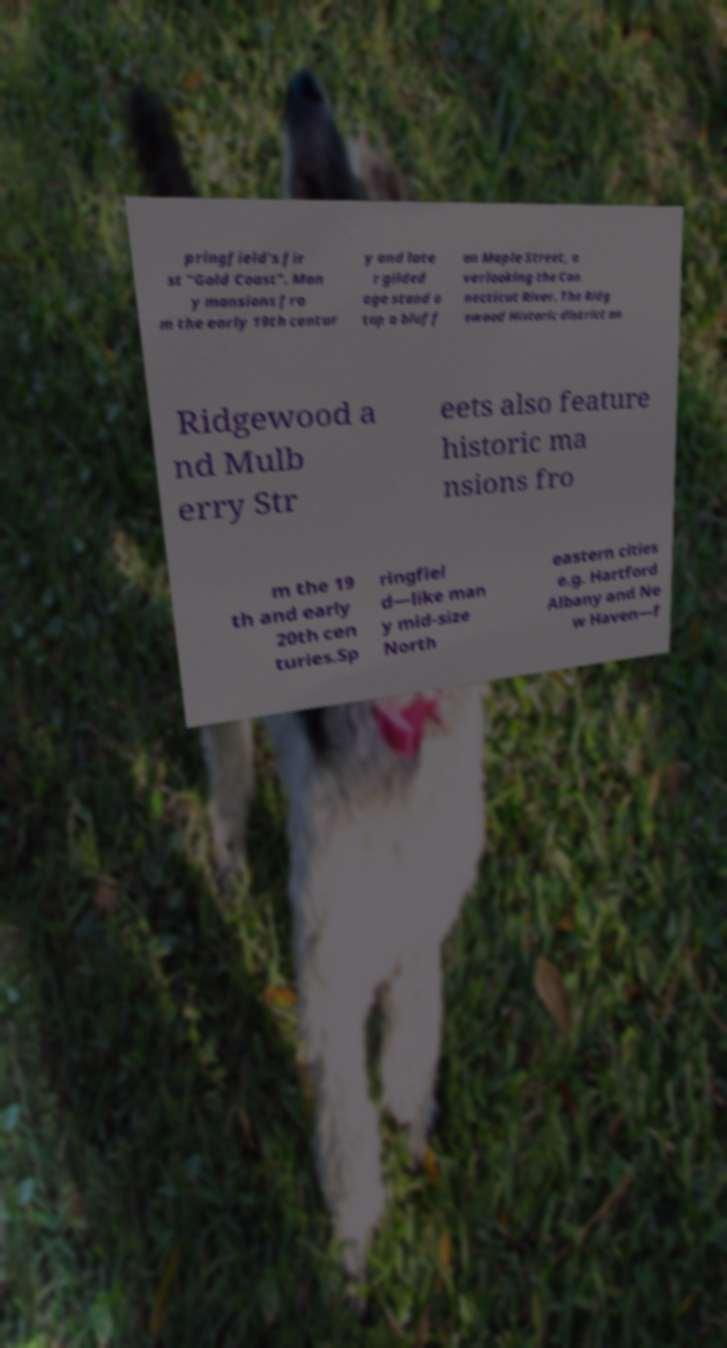Could you assist in decoding the text presented in this image and type it out clearly? pringfield's fir st "Gold Coast". Man y mansions fro m the early 19th centur y and late r gilded age stand a top a bluff on Maple Street, o verlooking the Con necticut River. The Ridg ewood Historic district on Ridgewood a nd Mulb erry Str eets also feature historic ma nsions fro m the 19 th and early 20th cen turies.Sp ringfiel d—like man y mid-size North eastern cities e.g. Hartford Albany and Ne w Haven—f 